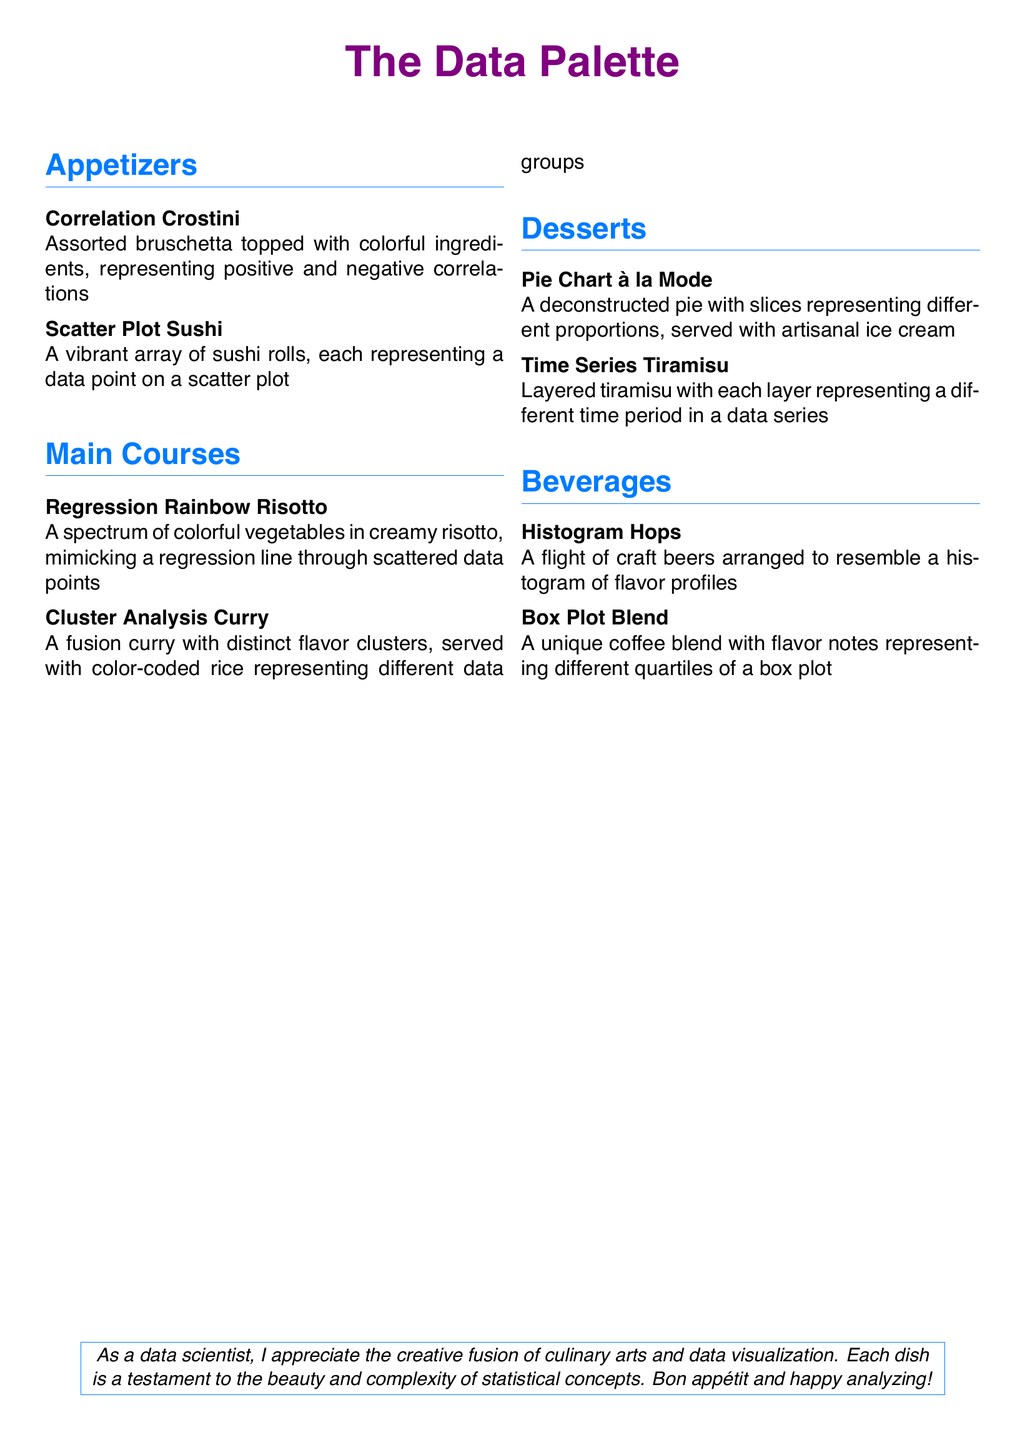What is the theme of the menu? The theme of the menu is a gourmet fusion inspired by data visualization techniques.
Answer: Data visualization How many appetizer dishes are listed? The number of appetizer dishes can be counted from the document. There are two listed under appetizers.
Answer: 2 What is the name of the dessert that represents a data series? The dessert that represents a data series is indicated in the document.
Answer: Time Series Tiramisu Which dish features colorful vegetables mimicking a regression line? The dish that features colorful vegetables mimicking a regression line is mentioned in the main courses section.
Answer: Regression Rainbow Risotto What color is used for the title of the menu? The menu's title color is described in the document.
Answer: Purple What does the "Cluster Analysis Curry" represent? The representation of the "Cluster Analysis Curry" is described as having distinct flavor clusters and color-coded rice representing different data groups.
Answer: Flavor clusters How many beverages are featured in the menu? The total number of beverages can be confirmed from the beverage section of the document. There are two featured.
Answer: 2 What is served with the "Pie Chart à la Mode"? The accompanying item for the "Pie Chart à la Mode" is specified in the dessert section.
Answer: Artisanal ice cream What visual concept is used in "Histogram Hops"? The visual concept for the "Histogram Hops" is based on the arrangement of craft beers.
Answer: Histogram 